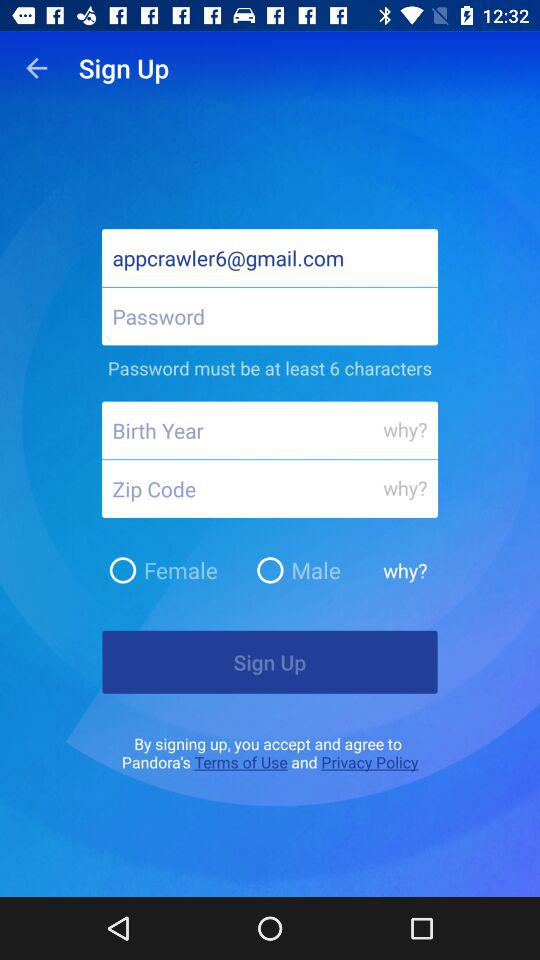How many characters must be included in the password? The password must include at least 6 characters. 